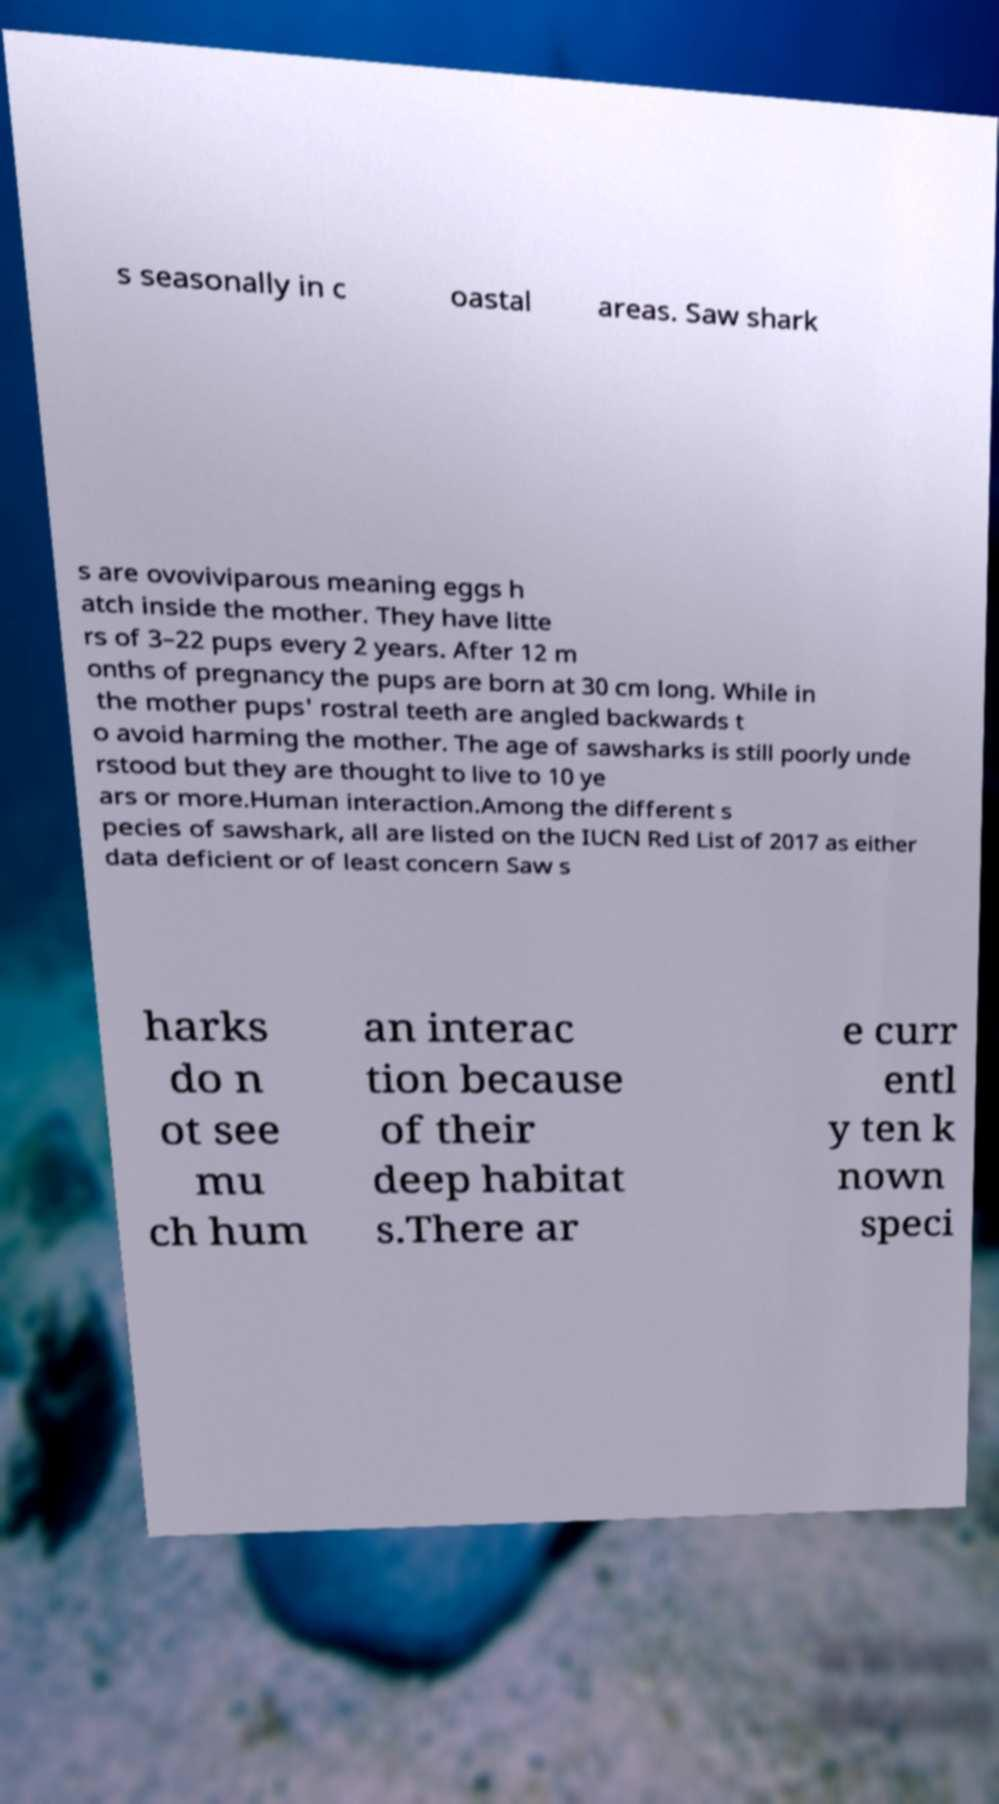Please identify and transcribe the text found in this image. s seasonally in c oastal areas. Saw shark s are ovoviviparous meaning eggs h atch inside the mother. They have litte rs of 3–22 pups every 2 years. After 12 m onths of pregnancy the pups are born at 30 cm long. While in the mother pups' rostral teeth are angled backwards t o avoid harming the mother. The age of sawsharks is still poorly unde rstood but they are thought to live to 10 ye ars or more.Human interaction.Among the different s pecies of sawshark, all are listed on the IUCN Red List of 2017 as either data deficient or of least concern Saw s harks do n ot see mu ch hum an interac tion because of their deep habitat s.There ar e curr entl y ten k nown speci 